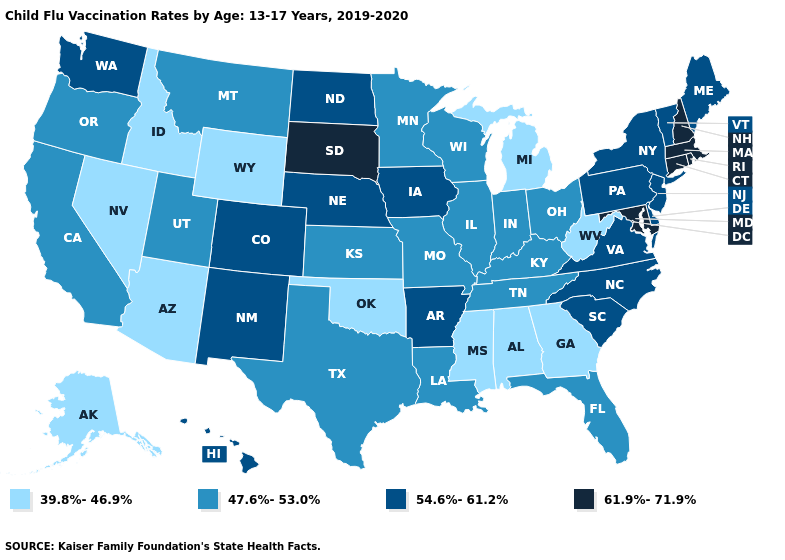Name the states that have a value in the range 61.9%-71.9%?
Keep it brief. Connecticut, Maryland, Massachusetts, New Hampshire, Rhode Island, South Dakota. What is the value of Massachusetts?
Give a very brief answer. 61.9%-71.9%. Does the map have missing data?
Short answer required. No. What is the lowest value in the USA?
Answer briefly. 39.8%-46.9%. Does Iowa have a lower value than South Dakota?
Keep it brief. Yes. Name the states that have a value in the range 39.8%-46.9%?
Be succinct. Alabama, Alaska, Arizona, Georgia, Idaho, Michigan, Mississippi, Nevada, Oklahoma, West Virginia, Wyoming. Is the legend a continuous bar?
Write a very short answer. No. Name the states that have a value in the range 54.6%-61.2%?
Write a very short answer. Arkansas, Colorado, Delaware, Hawaii, Iowa, Maine, Nebraska, New Jersey, New Mexico, New York, North Carolina, North Dakota, Pennsylvania, South Carolina, Vermont, Virginia, Washington. Among the states that border Louisiana , does Mississippi have the lowest value?
Quick response, please. Yes. How many symbols are there in the legend?
Quick response, please. 4. Which states have the lowest value in the USA?
Be succinct. Alabama, Alaska, Arizona, Georgia, Idaho, Michigan, Mississippi, Nevada, Oklahoma, West Virginia, Wyoming. What is the highest value in the USA?
Quick response, please. 61.9%-71.9%. Does North Dakota have a higher value than Maryland?
Write a very short answer. No. 